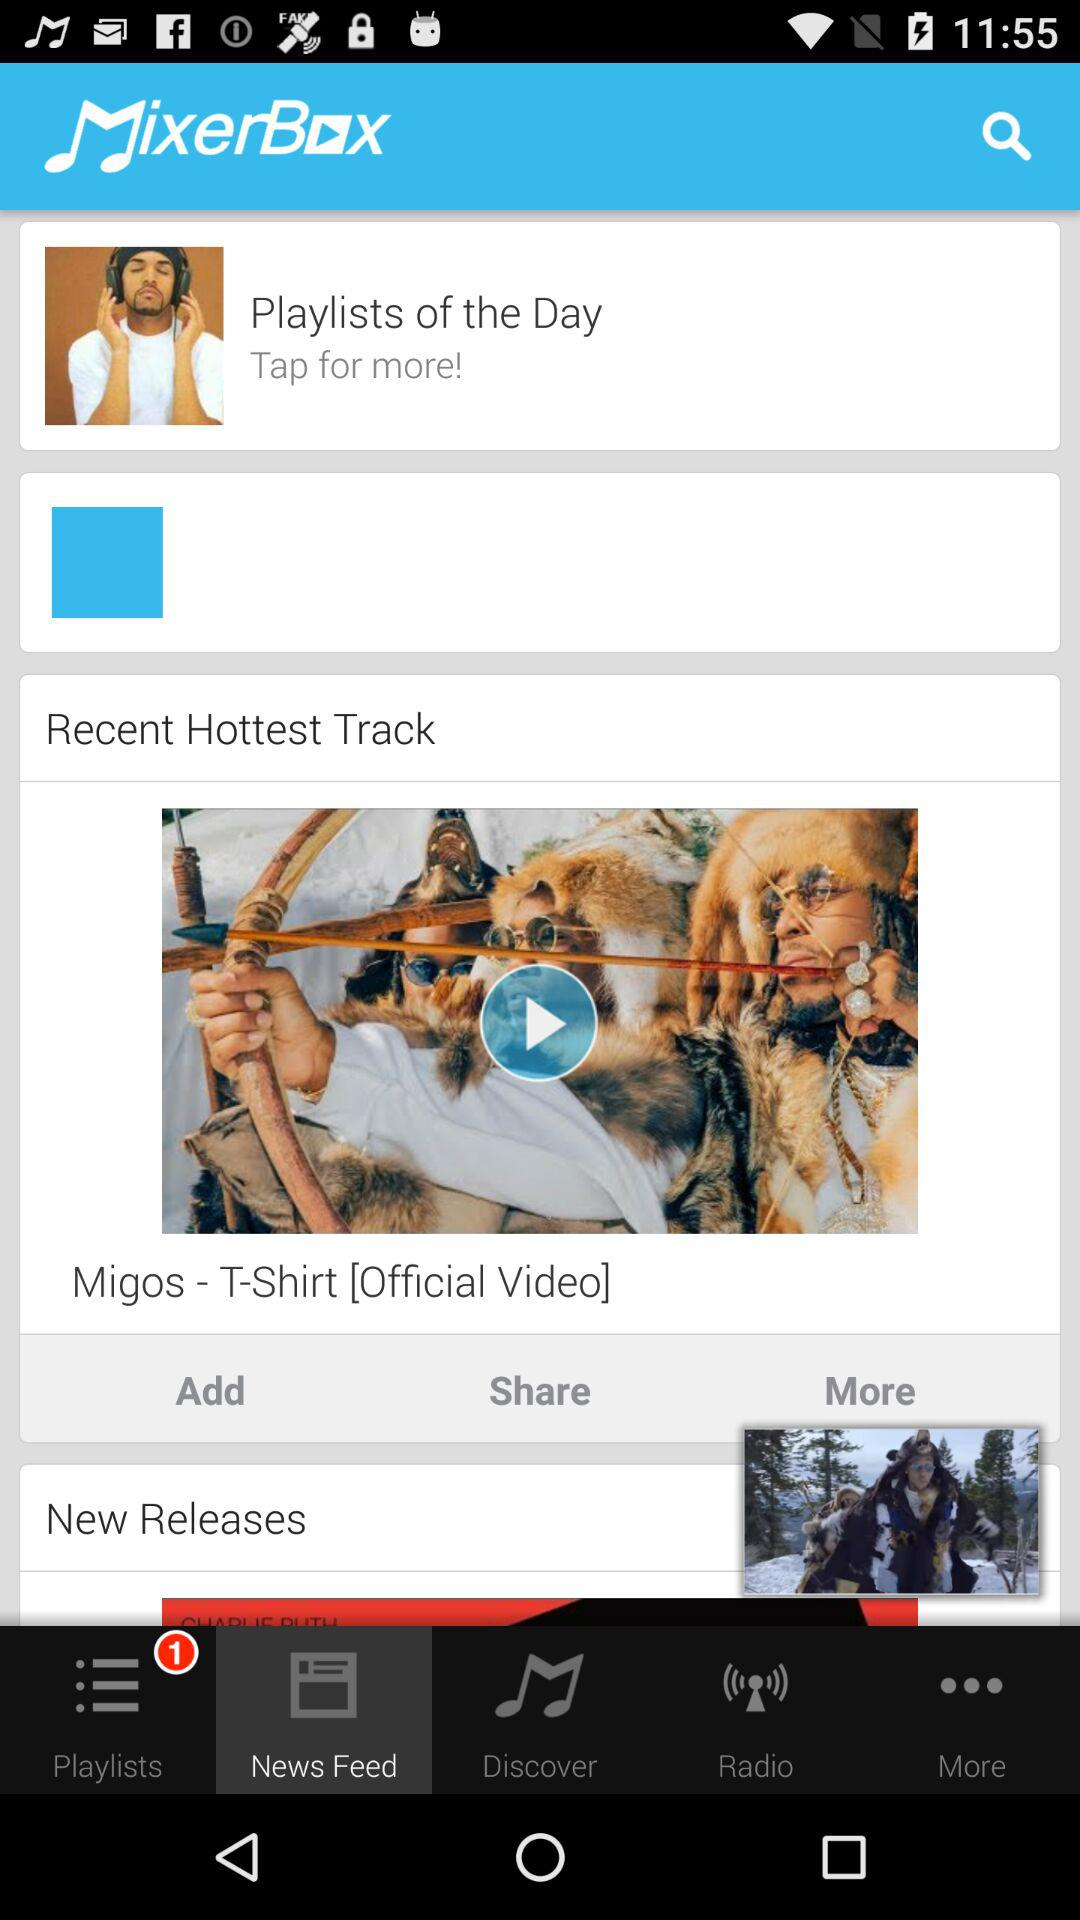Which tab is selected? The selected tab is "News Feed". 